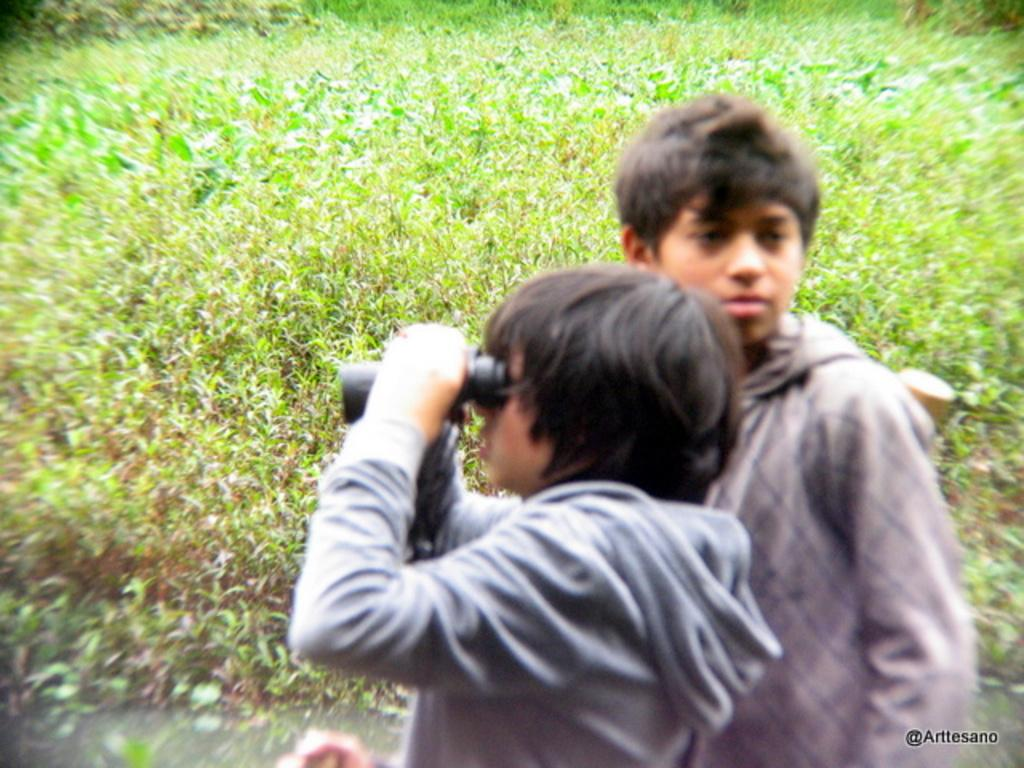Where was the image taken? The image was clicked outside. What can be seen in the middle of the image? There are two persons in the middle of the image. What is one of the persons holding? One of the persons is holding binoculars. What type of vegetation is visible in the background of the image? There are plants visible in the background of the image. What time of day is it in the image, based on the hour hand of the clock? There is no clock visible in the image, so it is not possible to determine the time of day based on the hour hand. 